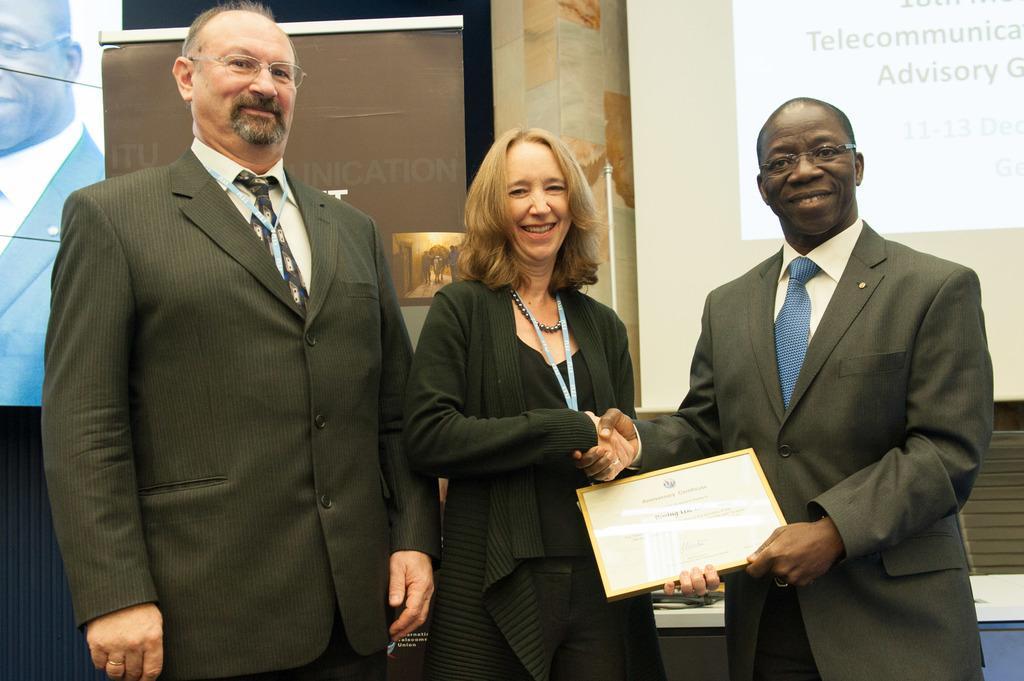In one or two sentences, can you explain what this image depicts? In this image, we can see people standing and wearing clothes. There are two persons shaking hands and holding a memorandum with their hands. There is a screen in the top right of the image. There is a banner on the left side of the image. 